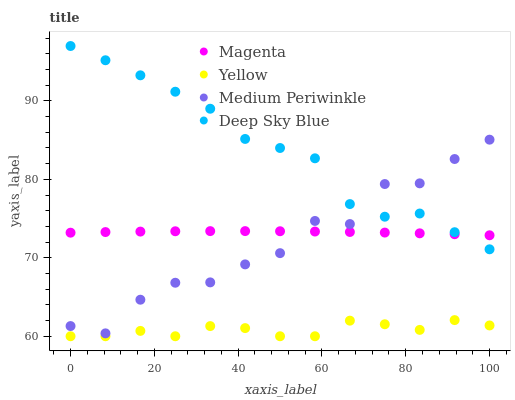Does Yellow have the minimum area under the curve?
Answer yes or no. Yes. Does Deep Sky Blue have the maximum area under the curve?
Answer yes or no. Yes. Does Medium Periwinkle have the minimum area under the curve?
Answer yes or no. No. Does Medium Periwinkle have the maximum area under the curve?
Answer yes or no. No. Is Magenta the smoothest?
Answer yes or no. Yes. Is Medium Periwinkle the roughest?
Answer yes or no. Yes. Is Deep Sky Blue the smoothest?
Answer yes or no. No. Is Deep Sky Blue the roughest?
Answer yes or no. No. Does Yellow have the lowest value?
Answer yes or no. Yes. Does Medium Periwinkle have the lowest value?
Answer yes or no. No. Does Deep Sky Blue have the highest value?
Answer yes or no. Yes. Does Medium Periwinkle have the highest value?
Answer yes or no. No. Is Yellow less than Deep Sky Blue?
Answer yes or no. Yes. Is Medium Periwinkle greater than Yellow?
Answer yes or no. Yes. Does Deep Sky Blue intersect Magenta?
Answer yes or no. Yes. Is Deep Sky Blue less than Magenta?
Answer yes or no. No. Is Deep Sky Blue greater than Magenta?
Answer yes or no. No. Does Yellow intersect Deep Sky Blue?
Answer yes or no. No. 